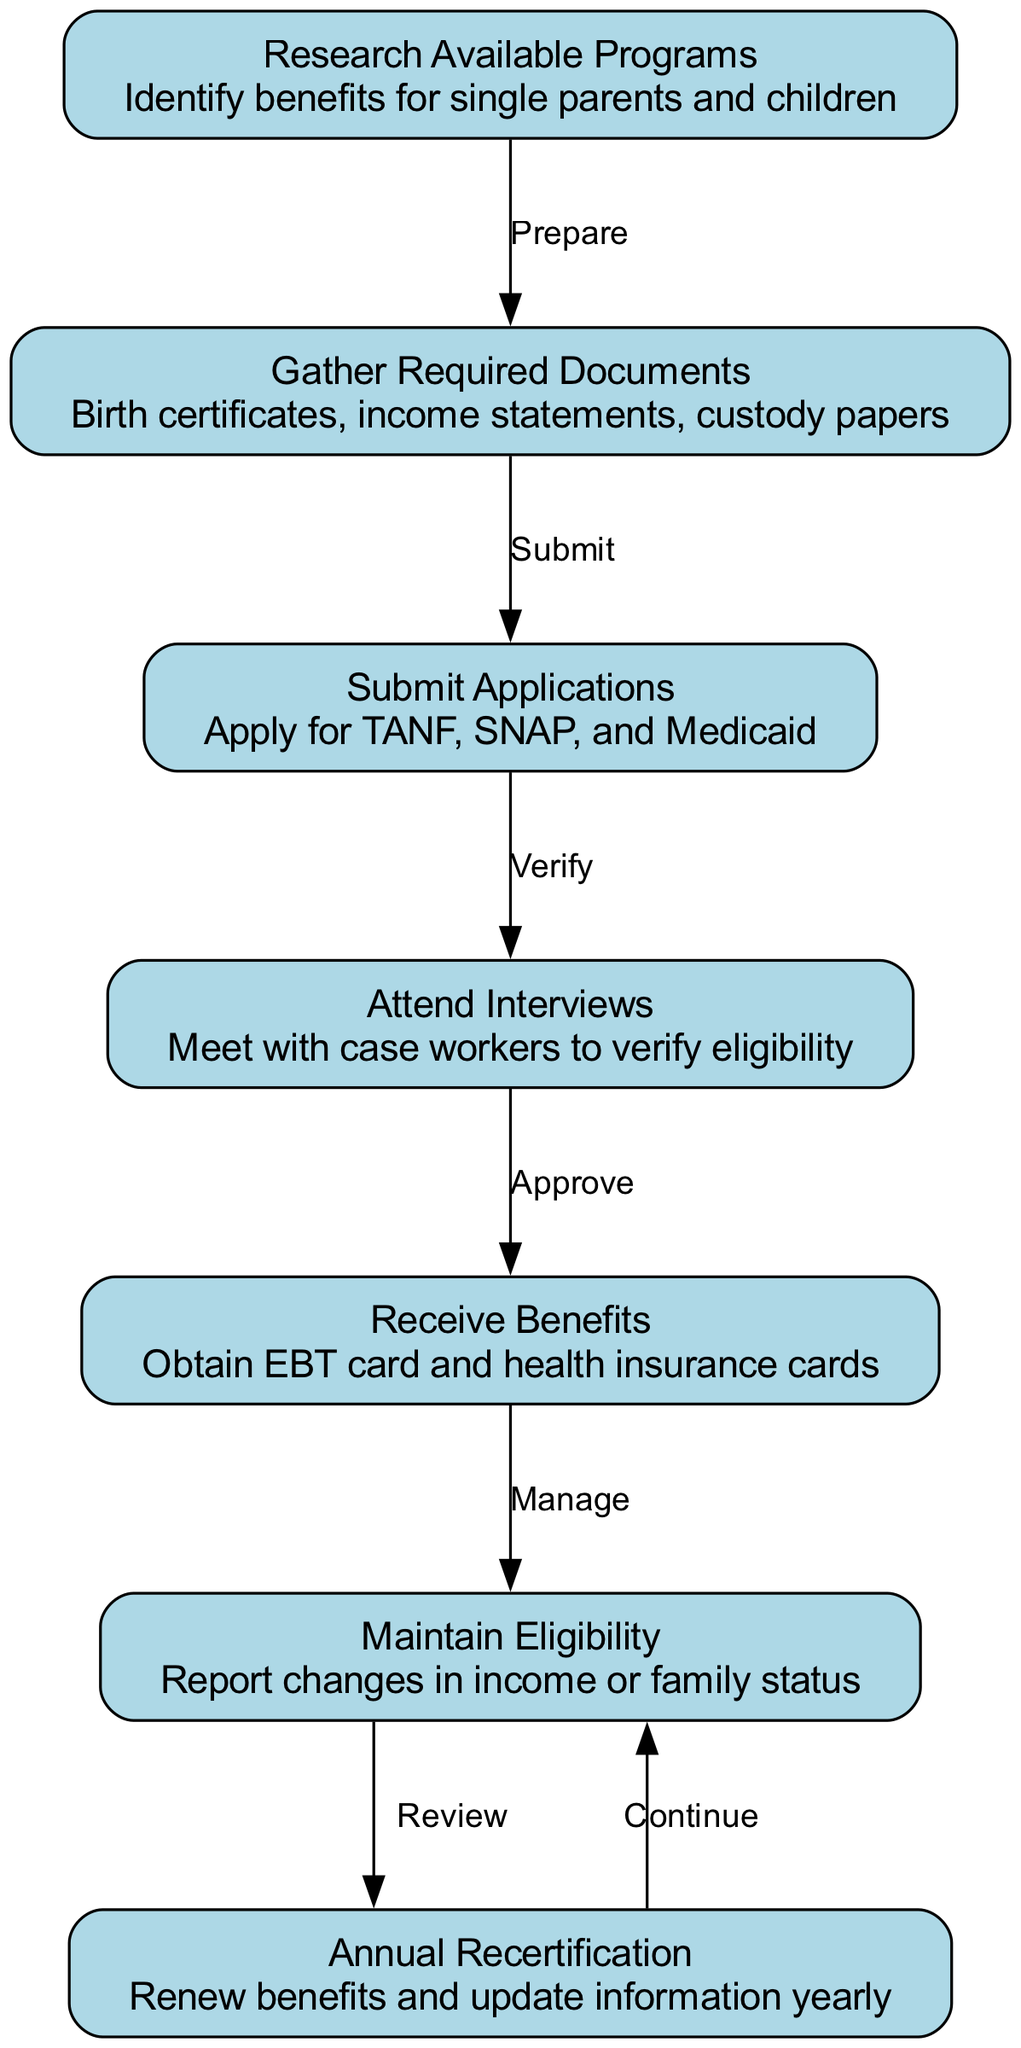what is the first step in the process? The first step is "Research Available Programs," which indicates the need to identify benefits for single parents and children.
Answer: Research Available Programs how many nodes are in the diagram? There are seven nodes listed in the diagram that represent different steps in the process of applying for and managing benefits.
Answer: 7 which two steps do you need to complete before submitting applications? The two steps are "Gather Required Documents" followed by "Submit Applications." The diagram flows from the first to the second step before reaching the applications.
Answer: Gather Required Documents, Submit Applications what happens after attending interviews? After "Attend Interviews," the next step is "Receive Benefits," meaning that once the interviews are completed, benefits can be obtained.
Answer: Receive Benefits which step involves maintaining eligibility? The step that involves maintaining eligibility is "Maintain Eligibility," where reporting changes in income or family status is required.
Answer: Maintain Eligibility how is annual recertification related to maintaining eligibility? "Annual Recertification" follows "Maintain Eligibility." This step continues the review process, ensuring benefits are up to date every year.
Answer: Review how does the process flow after receiving benefits? After receiving benefits, the next action is to "Maintain Eligibility," indicating that managing ongoing eligibility is essential after obtaining benefits from the program.
Answer: Maintain Eligibility what is required yearly to continue receiving benefits? "Annual Recertification" is required yearly to renew benefits and update information, ensuring continued eligibility.
Answer: Annual Recertification 